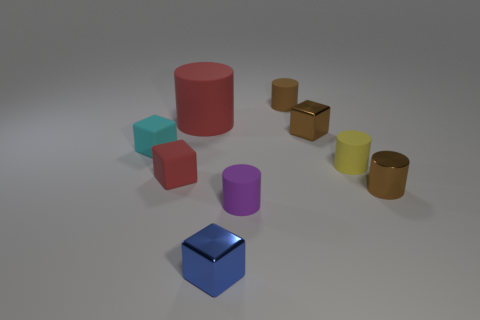Subtract all brown cubes. How many brown cylinders are left? 2 Subtract all tiny purple matte cylinders. How many cylinders are left? 4 Subtract all red cubes. How many cubes are left? 3 Subtract 1 cylinders. How many cylinders are left? 4 Subtract all yellow cylinders. Subtract all gray balls. How many cylinders are left? 4 Add 1 small brown metal cubes. How many objects exist? 10 Subtract all cylinders. How many objects are left? 4 Subtract 0 gray cylinders. How many objects are left? 9 Subtract all tiny blue things. Subtract all cubes. How many objects are left? 4 Add 2 tiny brown rubber cylinders. How many tiny brown rubber cylinders are left? 3 